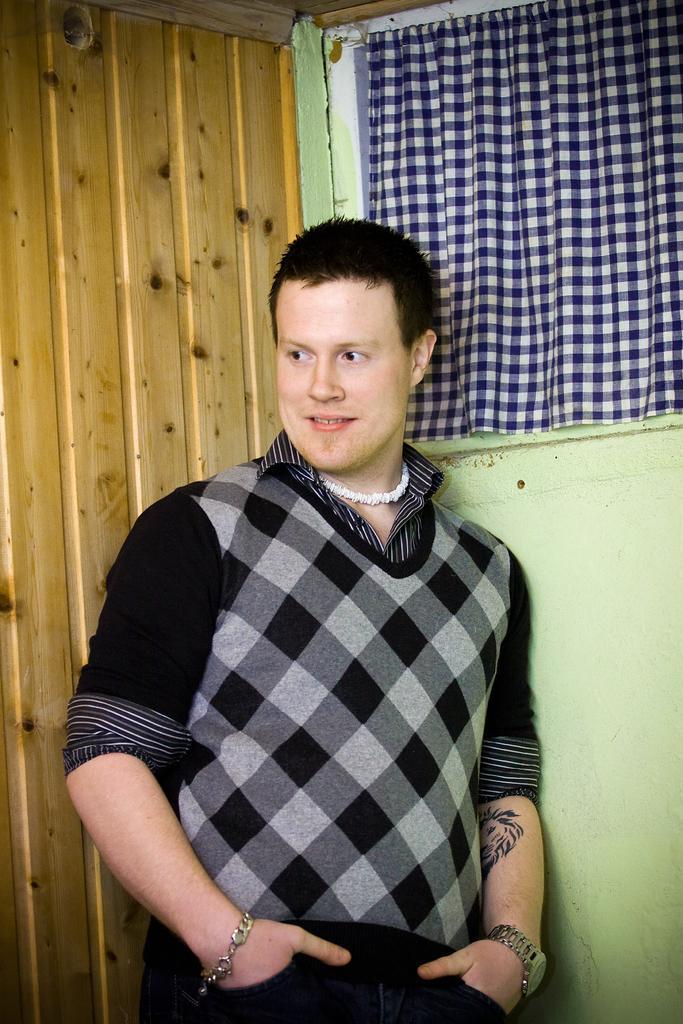Describe this image in one or two sentences. This picture is clicked inside. In the center there is a person wearing a black color t-shirt, smiling and standing. In the background there is a window, wall, curtain and a wooden door. 